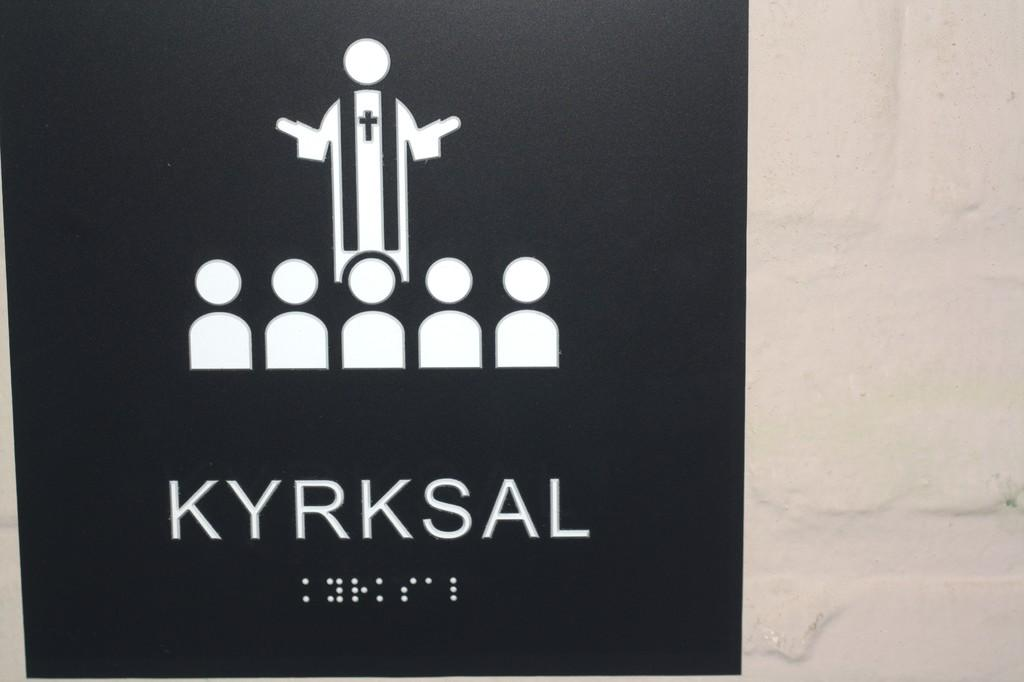<image>
Present a compact description of the photo's key features. A sign that has a jesus and children with the word kyrksal on it. 